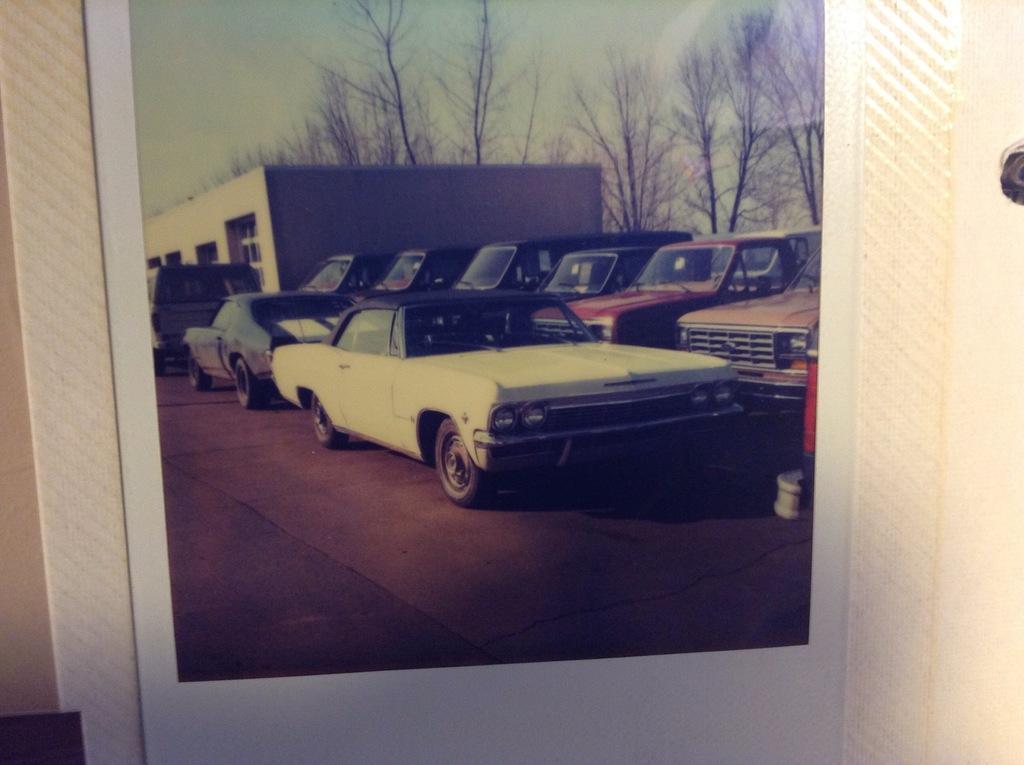In one or two sentences, can you explain what this image depicts? In this image there is a picture frame with a picture of a house, few trees and many cars. 